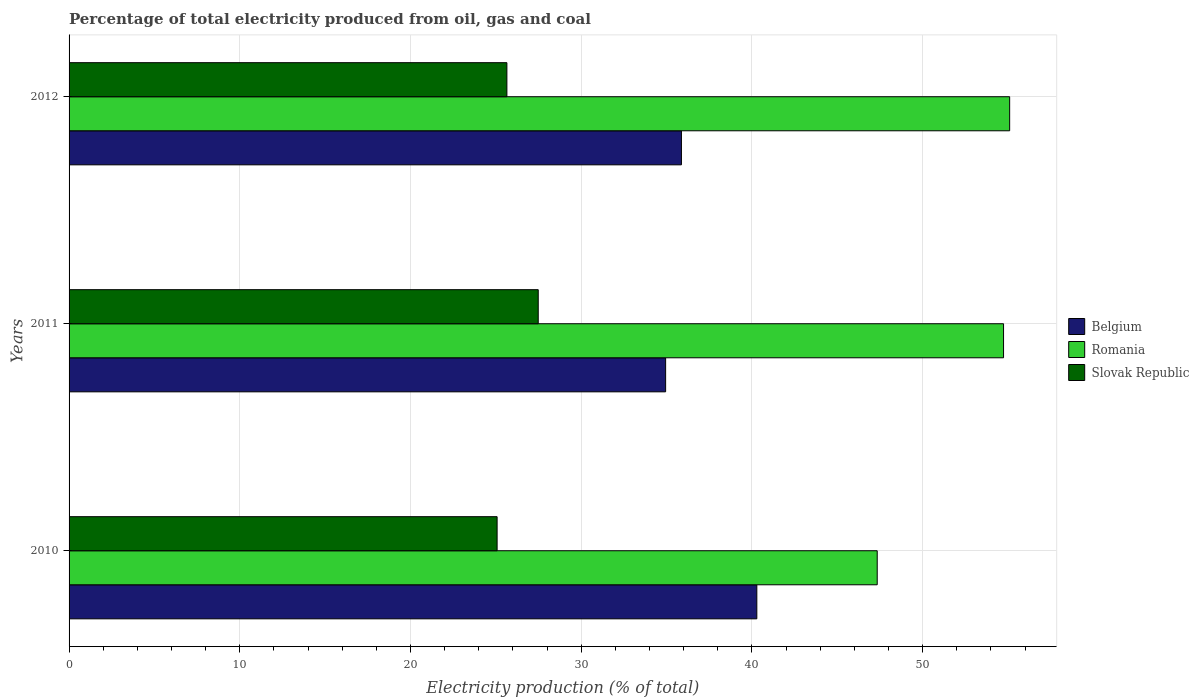How many different coloured bars are there?
Offer a very short reply. 3. Are the number of bars on each tick of the Y-axis equal?
Your answer should be compact. Yes. How many bars are there on the 3rd tick from the top?
Your answer should be compact. 3. What is the label of the 2nd group of bars from the top?
Your response must be concise. 2011. In how many cases, is the number of bars for a given year not equal to the number of legend labels?
Make the answer very short. 0. What is the electricity production in in Slovak Republic in 2012?
Give a very brief answer. 25.65. Across all years, what is the maximum electricity production in in Slovak Republic?
Keep it short and to the point. 27.48. Across all years, what is the minimum electricity production in in Belgium?
Offer a very short reply. 34.94. In which year was the electricity production in in Slovak Republic maximum?
Keep it short and to the point. 2011. In which year was the electricity production in in Slovak Republic minimum?
Make the answer very short. 2010. What is the total electricity production in in Romania in the graph?
Offer a very short reply. 157.17. What is the difference between the electricity production in in Belgium in 2010 and that in 2011?
Keep it short and to the point. 5.34. What is the difference between the electricity production in in Belgium in 2010 and the electricity production in in Romania in 2012?
Ensure brevity in your answer.  -14.81. What is the average electricity production in in Slovak Republic per year?
Give a very brief answer. 26.07. In the year 2012, what is the difference between the electricity production in in Slovak Republic and electricity production in in Romania?
Keep it short and to the point. -29.45. What is the ratio of the electricity production in in Slovak Republic in 2010 to that in 2011?
Keep it short and to the point. 0.91. What is the difference between the highest and the second highest electricity production in in Belgium?
Give a very brief answer. 4.42. What is the difference between the highest and the lowest electricity production in in Slovak Republic?
Make the answer very short. 2.41. In how many years, is the electricity production in in Belgium greater than the average electricity production in in Belgium taken over all years?
Provide a succinct answer. 1. Is the sum of the electricity production in in Slovak Republic in 2011 and 2012 greater than the maximum electricity production in in Romania across all years?
Give a very brief answer. No. What does the 3rd bar from the top in 2012 represents?
Give a very brief answer. Belgium. What does the 2nd bar from the bottom in 2011 represents?
Provide a short and direct response. Romania. Are all the bars in the graph horizontal?
Your answer should be very brief. Yes. What is the difference between two consecutive major ticks on the X-axis?
Your answer should be very brief. 10. Are the values on the major ticks of X-axis written in scientific E-notation?
Keep it short and to the point. No. Does the graph contain any zero values?
Offer a very short reply. No. Where does the legend appear in the graph?
Keep it short and to the point. Center right. How are the legend labels stacked?
Give a very brief answer. Vertical. What is the title of the graph?
Your answer should be very brief. Percentage of total electricity produced from oil, gas and coal. What is the label or title of the X-axis?
Your answer should be very brief. Electricity production (% of total). What is the Electricity production (% of total) in Belgium in 2010?
Provide a short and direct response. 40.29. What is the Electricity production (% of total) in Romania in 2010?
Provide a short and direct response. 47.34. What is the Electricity production (% of total) of Slovak Republic in 2010?
Keep it short and to the point. 25.07. What is the Electricity production (% of total) of Belgium in 2011?
Give a very brief answer. 34.94. What is the Electricity production (% of total) of Romania in 2011?
Your response must be concise. 54.74. What is the Electricity production (% of total) of Slovak Republic in 2011?
Your answer should be compact. 27.48. What is the Electricity production (% of total) of Belgium in 2012?
Ensure brevity in your answer.  35.87. What is the Electricity production (% of total) of Romania in 2012?
Your response must be concise. 55.1. What is the Electricity production (% of total) in Slovak Republic in 2012?
Provide a succinct answer. 25.65. Across all years, what is the maximum Electricity production (% of total) in Belgium?
Your answer should be very brief. 40.29. Across all years, what is the maximum Electricity production (% of total) of Romania?
Your answer should be compact. 55.1. Across all years, what is the maximum Electricity production (% of total) of Slovak Republic?
Your answer should be very brief. 27.48. Across all years, what is the minimum Electricity production (% of total) in Belgium?
Provide a short and direct response. 34.94. Across all years, what is the minimum Electricity production (% of total) of Romania?
Provide a short and direct response. 47.34. Across all years, what is the minimum Electricity production (% of total) in Slovak Republic?
Provide a short and direct response. 25.07. What is the total Electricity production (% of total) of Belgium in the graph?
Make the answer very short. 111.1. What is the total Electricity production (% of total) in Romania in the graph?
Provide a short and direct response. 157.17. What is the total Electricity production (% of total) in Slovak Republic in the graph?
Keep it short and to the point. 78.2. What is the difference between the Electricity production (% of total) in Belgium in 2010 and that in 2011?
Offer a very short reply. 5.34. What is the difference between the Electricity production (% of total) in Romania in 2010 and that in 2011?
Provide a succinct answer. -7.4. What is the difference between the Electricity production (% of total) of Slovak Republic in 2010 and that in 2011?
Keep it short and to the point. -2.41. What is the difference between the Electricity production (% of total) in Belgium in 2010 and that in 2012?
Your answer should be compact. 4.42. What is the difference between the Electricity production (% of total) in Romania in 2010 and that in 2012?
Your response must be concise. -7.76. What is the difference between the Electricity production (% of total) in Slovak Republic in 2010 and that in 2012?
Offer a terse response. -0.57. What is the difference between the Electricity production (% of total) of Belgium in 2011 and that in 2012?
Keep it short and to the point. -0.93. What is the difference between the Electricity production (% of total) in Romania in 2011 and that in 2012?
Provide a short and direct response. -0.36. What is the difference between the Electricity production (% of total) of Slovak Republic in 2011 and that in 2012?
Make the answer very short. 1.84. What is the difference between the Electricity production (% of total) in Belgium in 2010 and the Electricity production (% of total) in Romania in 2011?
Offer a very short reply. -14.45. What is the difference between the Electricity production (% of total) in Belgium in 2010 and the Electricity production (% of total) in Slovak Republic in 2011?
Ensure brevity in your answer.  12.8. What is the difference between the Electricity production (% of total) in Romania in 2010 and the Electricity production (% of total) in Slovak Republic in 2011?
Offer a terse response. 19.86. What is the difference between the Electricity production (% of total) of Belgium in 2010 and the Electricity production (% of total) of Romania in 2012?
Ensure brevity in your answer.  -14.81. What is the difference between the Electricity production (% of total) of Belgium in 2010 and the Electricity production (% of total) of Slovak Republic in 2012?
Your answer should be compact. 14.64. What is the difference between the Electricity production (% of total) in Romania in 2010 and the Electricity production (% of total) in Slovak Republic in 2012?
Give a very brief answer. 21.69. What is the difference between the Electricity production (% of total) of Belgium in 2011 and the Electricity production (% of total) of Romania in 2012?
Provide a short and direct response. -20.15. What is the difference between the Electricity production (% of total) of Belgium in 2011 and the Electricity production (% of total) of Slovak Republic in 2012?
Your answer should be compact. 9.3. What is the difference between the Electricity production (% of total) of Romania in 2011 and the Electricity production (% of total) of Slovak Republic in 2012?
Keep it short and to the point. 29.09. What is the average Electricity production (% of total) of Belgium per year?
Offer a terse response. 37.03. What is the average Electricity production (% of total) in Romania per year?
Ensure brevity in your answer.  52.39. What is the average Electricity production (% of total) of Slovak Republic per year?
Provide a succinct answer. 26.07. In the year 2010, what is the difference between the Electricity production (% of total) in Belgium and Electricity production (% of total) in Romania?
Keep it short and to the point. -7.05. In the year 2010, what is the difference between the Electricity production (% of total) of Belgium and Electricity production (% of total) of Slovak Republic?
Provide a short and direct response. 15.21. In the year 2010, what is the difference between the Electricity production (% of total) in Romania and Electricity production (% of total) in Slovak Republic?
Keep it short and to the point. 22.27. In the year 2011, what is the difference between the Electricity production (% of total) in Belgium and Electricity production (% of total) in Romania?
Ensure brevity in your answer.  -19.79. In the year 2011, what is the difference between the Electricity production (% of total) of Belgium and Electricity production (% of total) of Slovak Republic?
Your response must be concise. 7.46. In the year 2011, what is the difference between the Electricity production (% of total) of Romania and Electricity production (% of total) of Slovak Republic?
Your response must be concise. 27.26. In the year 2012, what is the difference between the Electricity production (% of total) in Belgium and Electricity production (% of total) in Romania?
Offer a very short reply. -19.23. In the year 2012, what is the difference between the Electricity production (% of total) of Belgium and Electricity production (% of total) of Slovak Republic?
Provide a short and direct response. 10.22. In the year 2012, what is the difference between the Electricity production (% of total) of Romania and Electricity production (% of total) of Slovak Republic?
Your answer should be very brief. 29.45. What is the ratio of the Electricity production (% of total) in Belgium in 2010 to that in 2011?
Give a very brief answer. 1.15. What is the ratio of the Electricity production (% of total) of Romania in 2010 to that in 2011?
Give a very brief answer. 0.86. What is the ratio of the Electricity production (% of total) of Slovak Republic in 2010 to that in 2011?
Ensure brevity in your answer.  0.91. What is the ratio of the Electricity production (% of total) of Belgium in 2010 to that in 2012?
Your response must be concise. 1.12. What is the ratio of the Electricity production (% of total) of Romania in 2010 to that in 2012?
Your answer should be very brief. 0.86. What is the ratio of the Electricity production (% of total) in Slovak Republic in 2010 to that in 2012?
Give a very brief answer. 0.98. What is the ratio of the Electricity production (% of total) in Belgium in 2011 to that in 2012?
Provide a succinct answer. 0.97. What is the ratio of the Electricity production (% of total) of Slovak Republic in 2011 to that in 2012?
Keep it short and to the point. 1.07. What is the difference between the highest and the second highest Electricity production (% of total) in Belgium?
Your response must be concise. 4.42. What is the difference between the highest and the second highest Electricity production (% of total) of Romania?
Ensure brevity in your answer.  0.36. What is the difference between the highest and the second highest Electricity production (% of total) in Slovak Republic?
Your answer should be very brief. 1.84. What is the difference between the highest and the lowest Electricity production (% of total) in Belgium?
Keep it short and to the point. 5.34. What is the difference between the highest and the lowest Electricity production (% of total) in Romania?
Provide a succinct answer. 7.76. What is the difference between the highest and the lowest Electricity production (% of total) of Slovak Republic?
Your answer should be very brief. 2.41. 